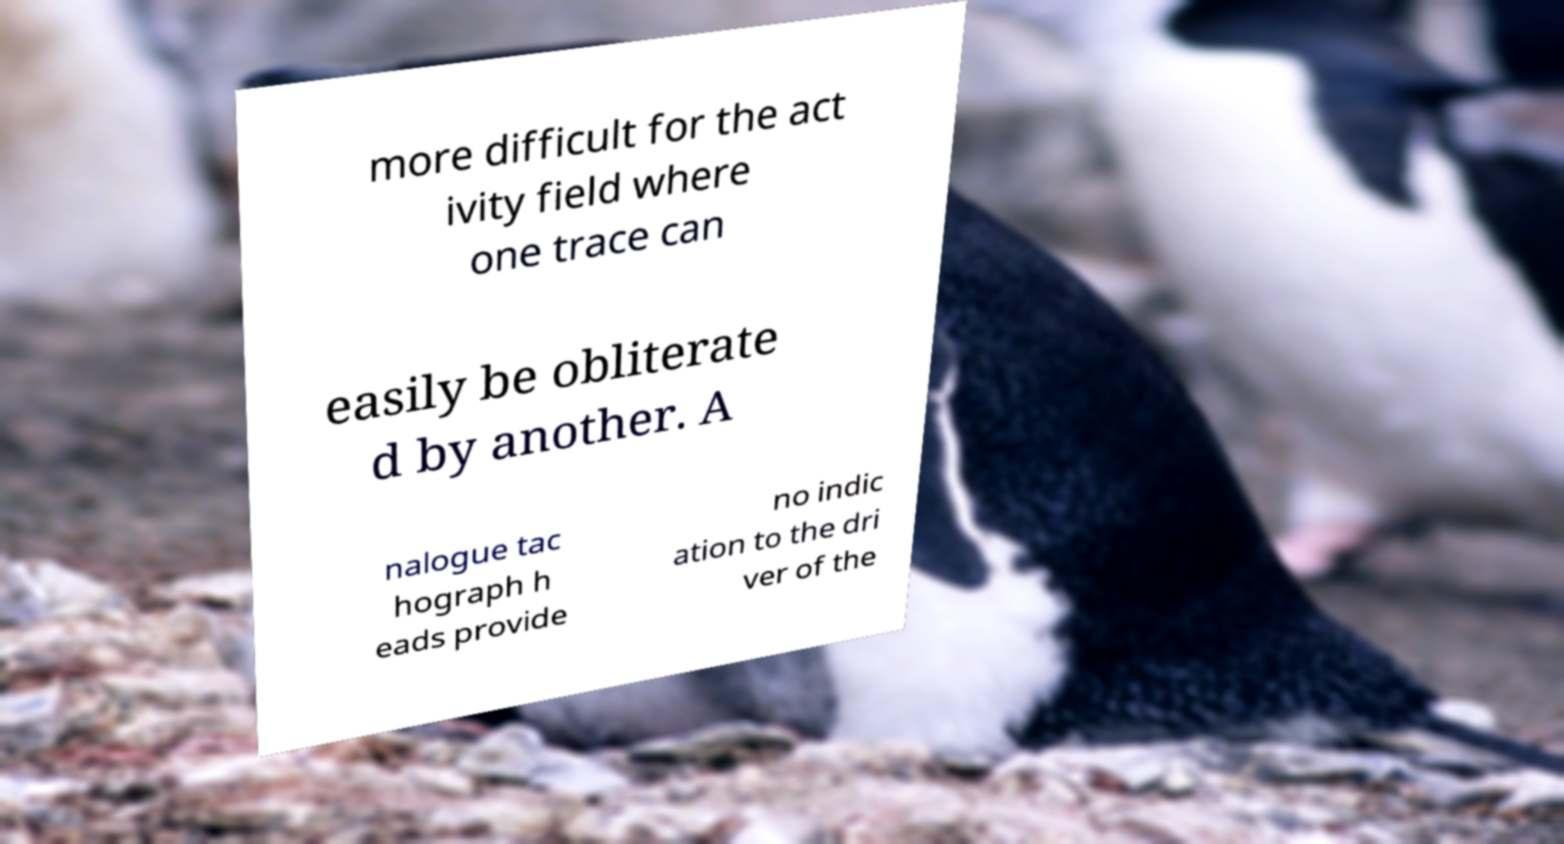Please read and relay the text visible in this image. What does it say? more difficult for the act ivity field where one trace can easily be obliterate d by another. A nalogue tac hograph h eads provide no indic ation to the dri ver of the 